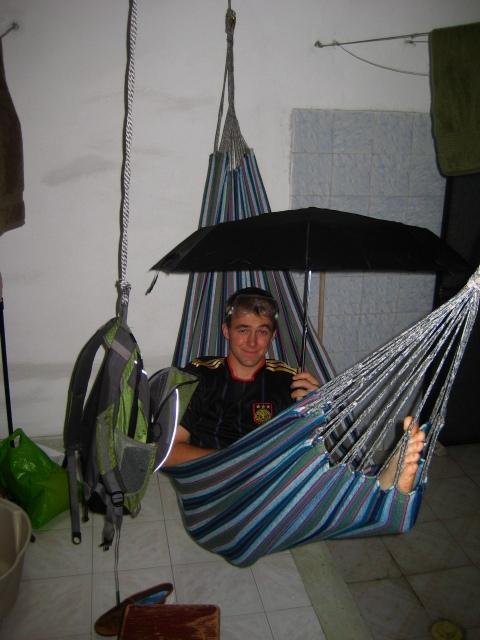How many people are in the photo?
Give a very brief answer. 1. How many laptops are there on the table?
Give a very brief answer. 0. 